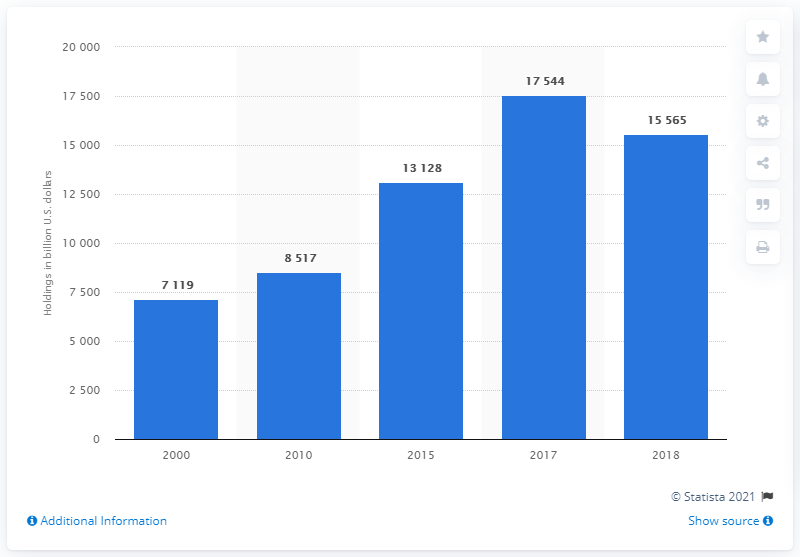Specify some key components in this picture. In 2018, the household sector held approximately 15,565 dollars in equities. 